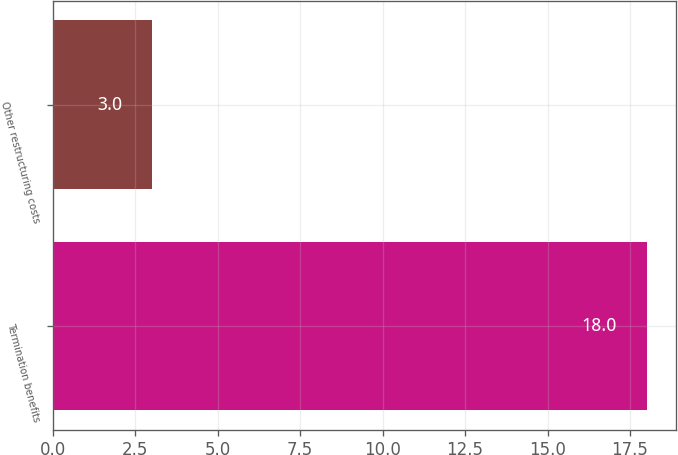Convert chart to OTSL. <chart><loc_0><loc_0><loc_500><loc_500><bar_chart><fcel>Termination benefits<fcel>Other restructuring costs<nl><fcel>18<fcel>3<nl></chart> 